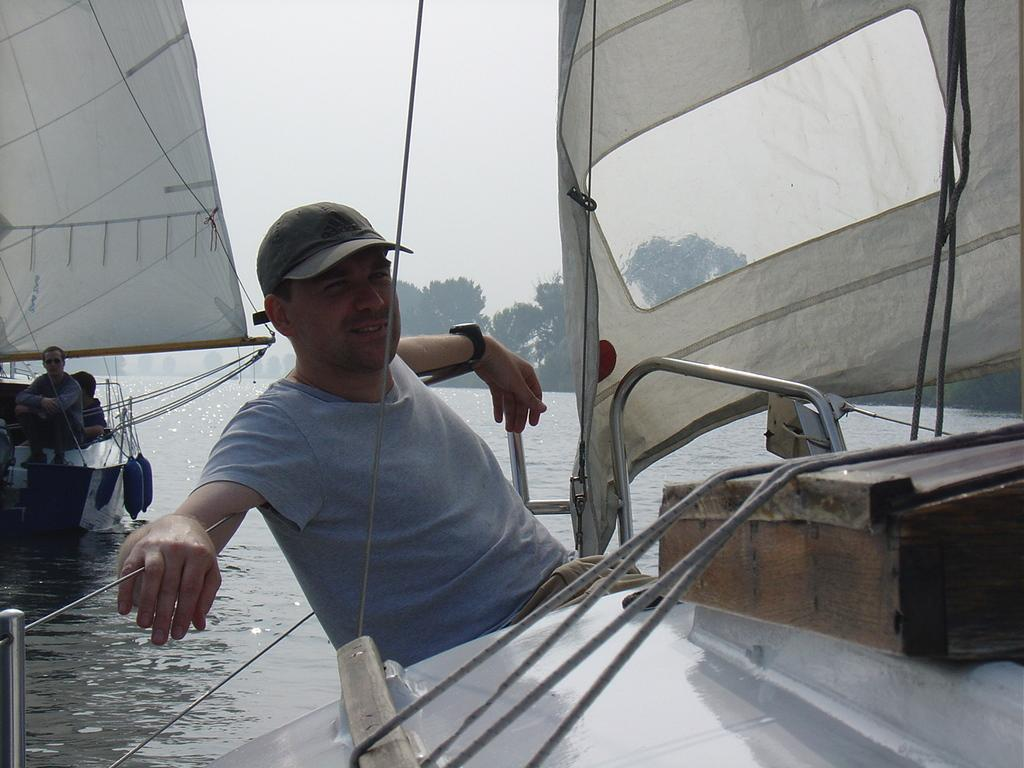What is the primary element in the image? There is water in the image. What is on the water? There are boats on the water. What are the people on the boats doing? People are sitting on the boats. What can be seen in the background of the image? There are trees visible in the background of the image. Can you tell me how many basketballs are floating in the water? There are no basketballs present in the image; it features water, boats, and people sitting on the boats. What type of yak can be seen grazing near the trees in the background? There is no yak present in the image; only trees are visible in the background. 